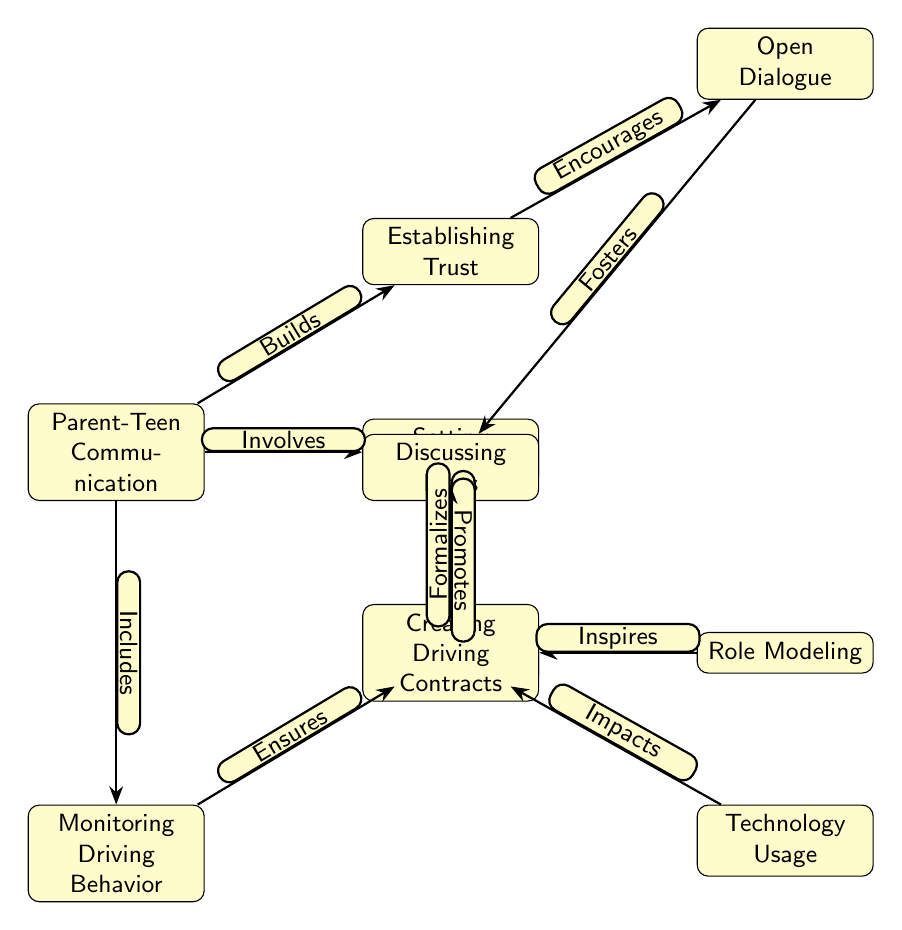What is the central node of the diagram? The diagram's central node is "Parent-Teen Communication," which acts as the base from which all other nodes and relationships flow. It is explicitly highlighted as the starting point for various facets that influence safe driving practices.
Answer: Parent-Teen Communication How many nodes are present in the diagram? To find the number of nodes, we can count each distinct element within the diagram. There are 10 nodes in total: Parent-Teen Communication, Safe Driving Practices, Establishing Trust, Setting Boundaries, Monitoring Driving Behavior, Open Dialogue, Role Modeling, Discussing Risks, Technology Usage, and Creating Driving Contracts.
Answer: 10 Which node is directly connected to "Safe Driving Practices" and "Establishing Trust"? The node "Parent-Teen Communication" is the only one that connects directly to both "Safe Driving Practices" and "Establishing Trust." These links highlight the role of communication in fostering safe driving habits and building trust.
Answer: Parent-Teen Communication What effect does "Open Dialogue" have on "Discussing Risks"? "Open Dialogue" fosters "Discussing Risks," creating a positive relationship where communication invites discussions around the potential dangers associated with driving. This connection emphasizes the importance of open discussions in risk awareness among teens.
Answer: Fosters What is the relationship between "Role Modeling" and "Safe Driving Practices"? The relationship indicates that "Role Modeling" inspires "Safe Driving Practices." This suggests that the behaviors exhibited by parents can significantly influence teens' driving habits, demonstrating that parents serve as key examples in promoting safe driving.
Answer: Inspires How are "Setting Boundaries" and "Creating Driving Contracts" related in the diagram? "Setting Boundaries" reinforces "Creating Driving Contracts." This shows that establishing limits and guidelines provided through contracts is part of a larger framework of boundary-setting in parent-teen interactions around driving.
Answer: Reinforces What is a consequence of "Technology Usage" according to the diagram? "Technology Usage" impacts "Safe Driving Practices," indicating that how technology is utilized by teens can significantly influence their driving behavior, potentially posing risks when mismanaged.
Answer: Impacts Name the node that discusses risks associated with driving. The node is "Discussing Risks," which emphasizes the need for conversations about potential dangers faced while driving, ensuring that teens are aware of and understand those risks.
Answer: Discussing Risks Which node is connected to "Monitoring Driving Behavior"? The node "Parent-Teen Communication" is connected to "Monitoring Driving Behavior," indicating that effective communication between parents and teens can lead to better monitoring of driving practices.
Answer: Parent-Teen Communication 